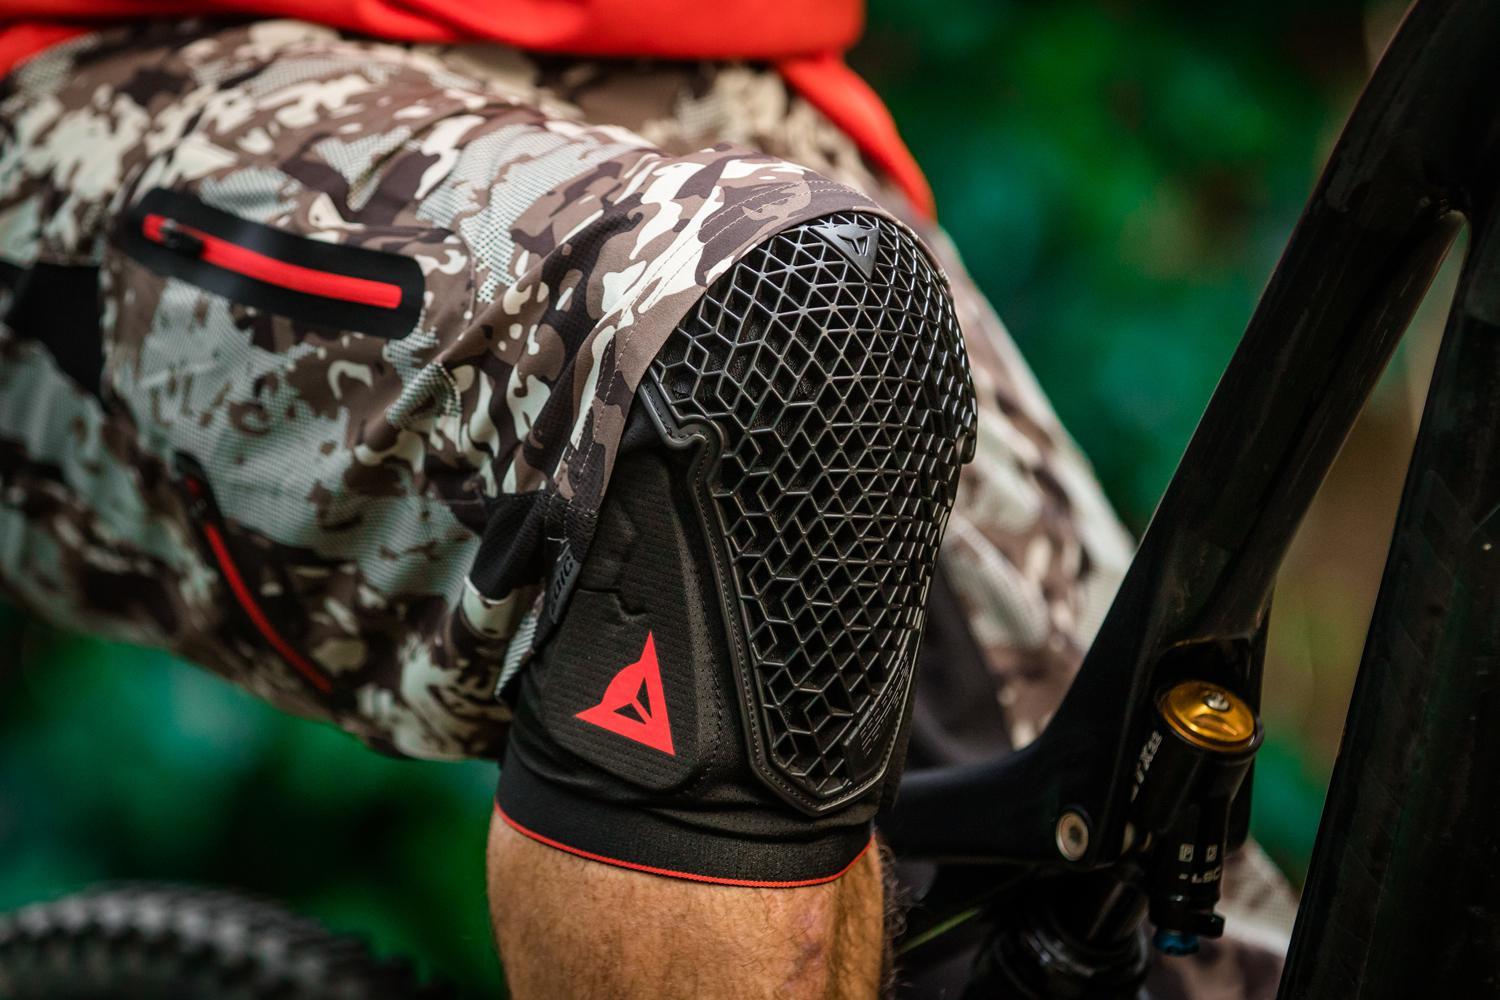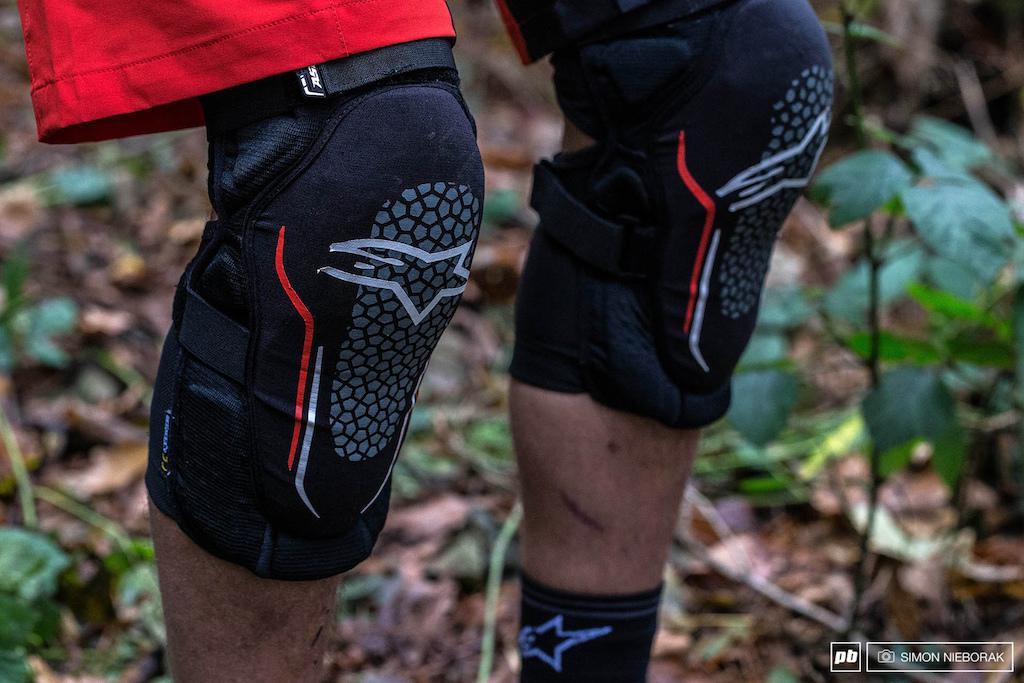The first image is the image on the left, the second image is the image on the right. For the images shown, is this caption "A person is wearing two knee braces in the image on the left." true? Answer yes or no. No. The first image is the image on the left, the second image is the image on the right. Analyze the images presented: Is the assertion "In one image, a person is wearing a pair of knee pads with shorts, while the second image is one knee pad displayed on a model leg." valid? Answer yes or no. No. 